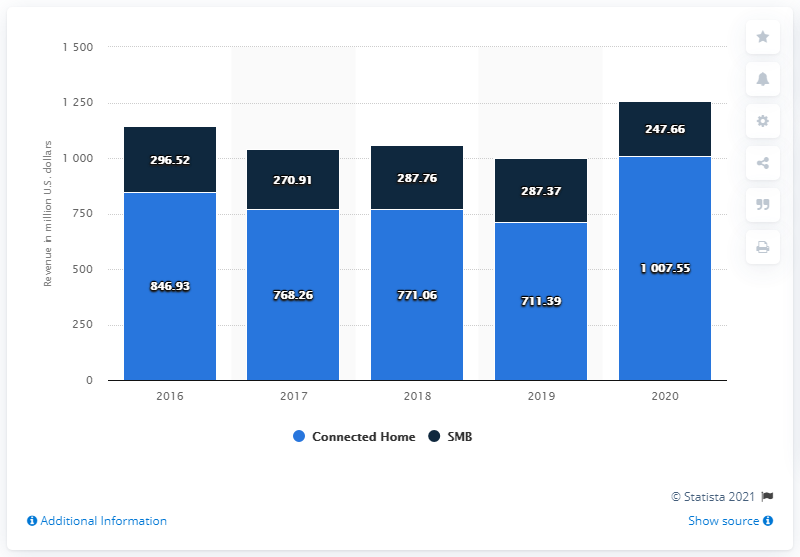Identify some key points in this picture. Netgear's revenue from its connected home segment in 2019 was approximately $771.06 million. 